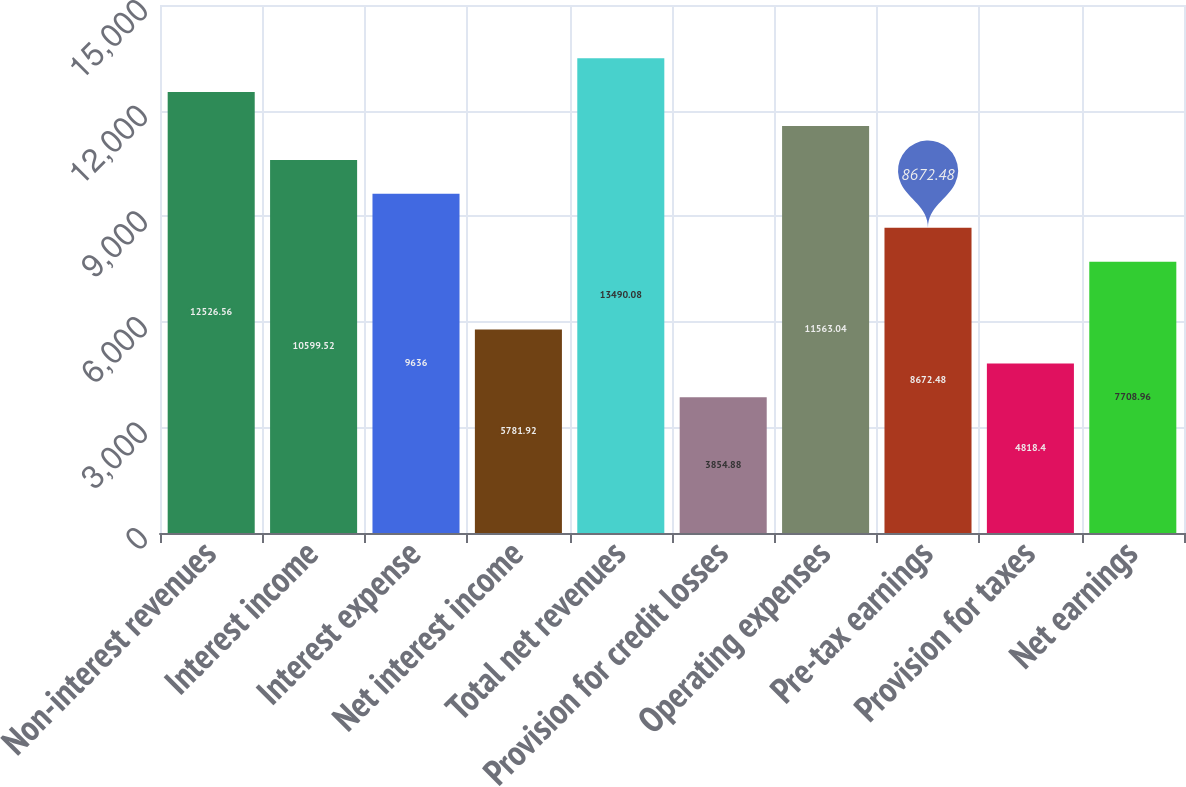Convert chart to OTSL. <chart><loc_0><loc_0><loc_500><loc_500><bar_chart><fcel>Non-interest revenues<fcel>Interest income<fcel>Interest expense<fcel>Net interest income<fcel>Total net revenues<fcel>Provision for credit losses<fcel>Operating expenses<fcel>Pre-tax earnings<fcel>Provision for taxes<fcel>Net earnings<nl><fcel>12526.6<fcel>10599.5<fcel>9636<fcel>5781.92<fcel>13490.1<fcel>3854.88<fcel>11563<fcel>8672.48<fcel>4818.4<fcel>7708.96<nl></chart> 